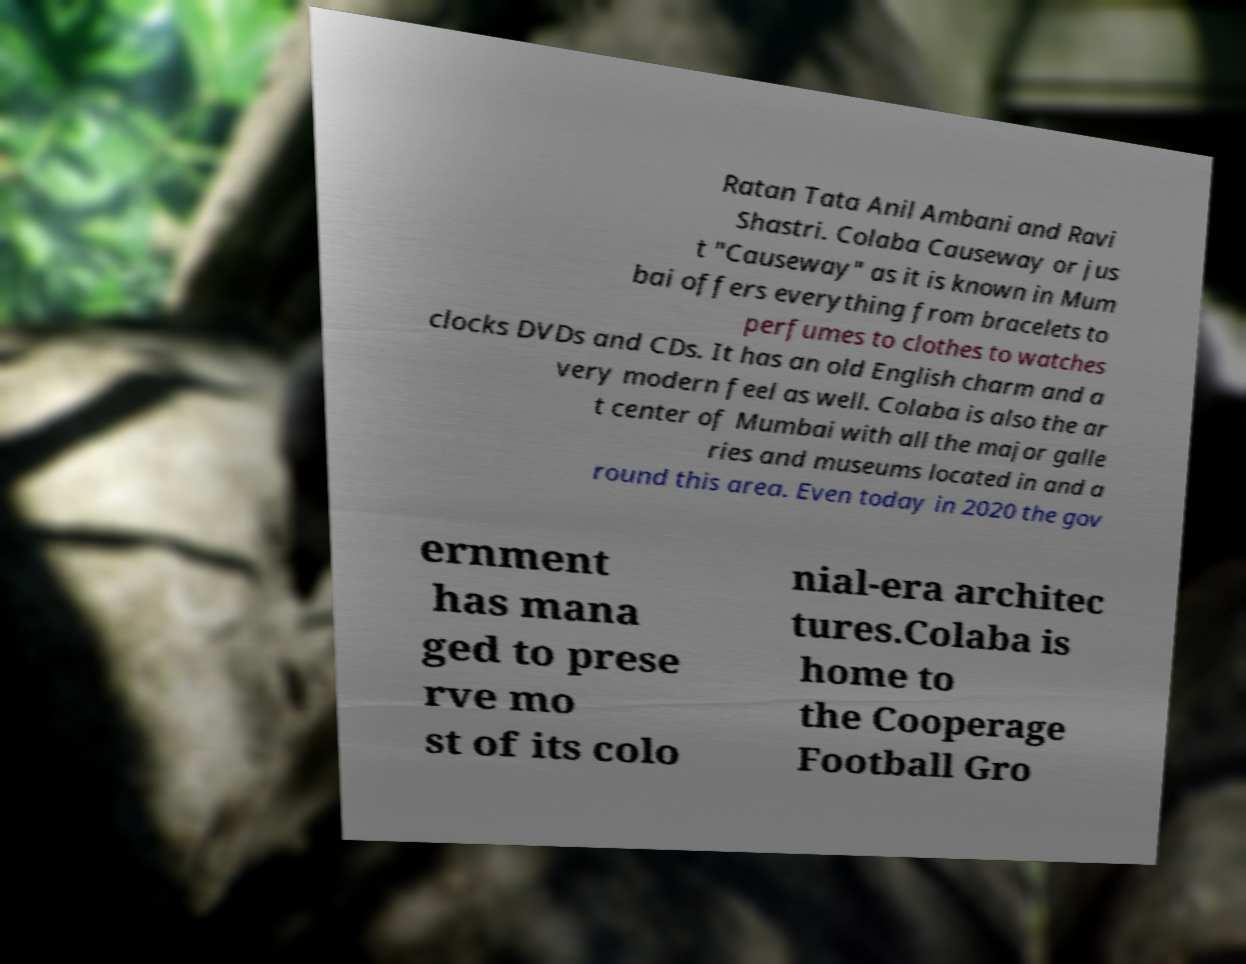Can you accurately transcribe the text from the provided image for me? Ratan Tata Anil Ambani and Ravi Shastri. Colaba Causeway or jus t "Causeway" as it is known in Mum bai offers everything from bracelets to perfumes to clothes to watches clocks DVDs and CDs. It has an old English charm and a very modern feel as well. Colaba is also the ar t center of Mumbai with all the major galle ries and museums located in and a round this area. Even today in 2020 the gov ernment has mana ged to prese rve mo st of its colo nial-era architec tures.Colaba is home to the Cooperage Football Gro 